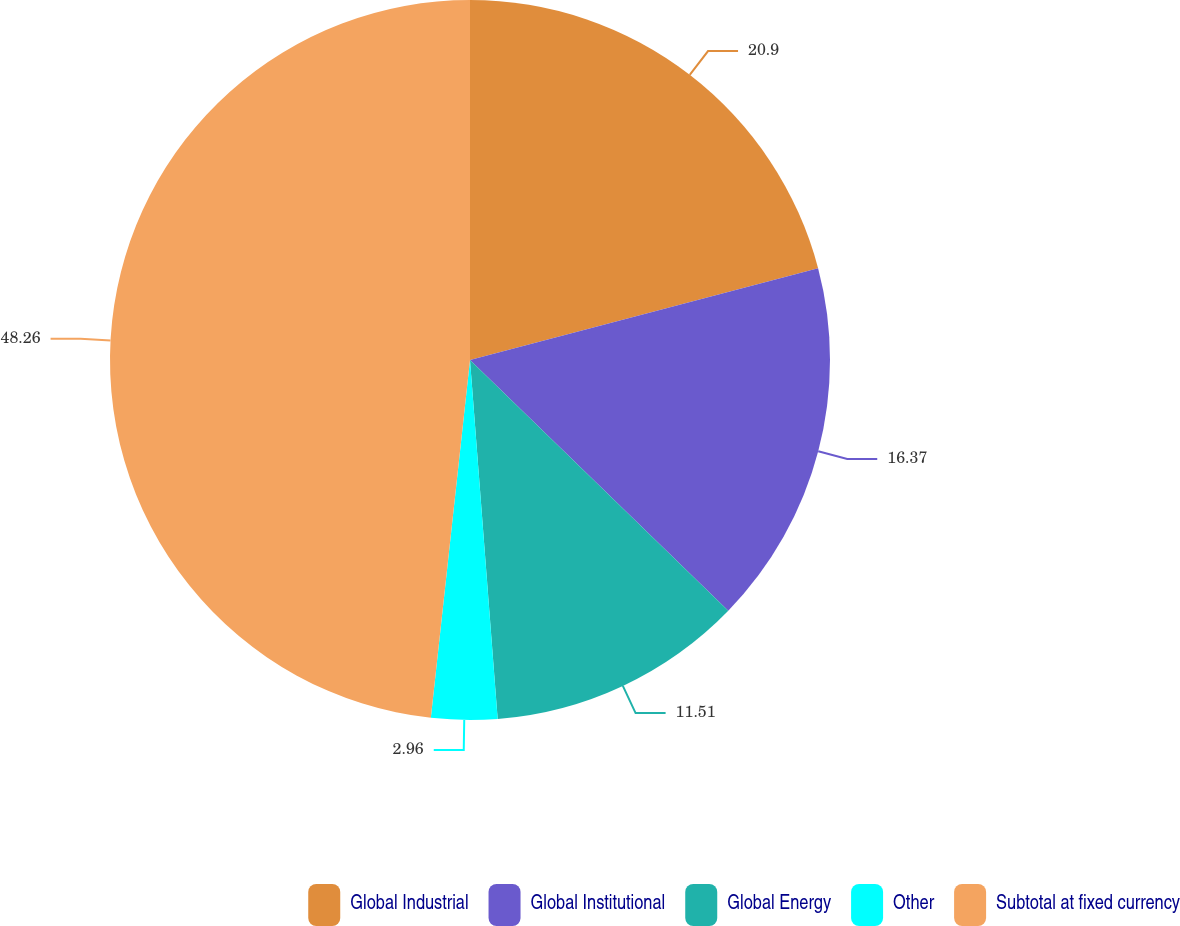<chart> <loc_0><loc_0><loc_500><loc_500><pie_chart><fcel>Global Industrial<fcel>Global Institutional<fcel>Global Energy<fcel>Other<fcel>Subtotal at fixed currency<nl><fcel>20.9%<fcel>16.37%<fcel>11.51%<fcel>2.96%<fcel>48.27%<nl></chart> 